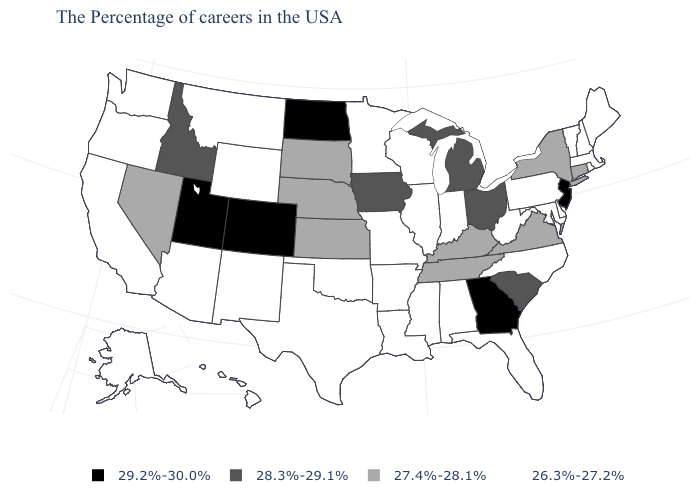Among the states that border Oklahoma , which have the lowest value?
Short answer required. Missouri, Arkansas, Texas, New Mexico. Which states hav the highest value in the West?
Answer briefly. Colorado, Utah. Name the states that have a value in the range 26.3%-27.2%?
Answer briefly. Maine, Massachusetts, Rhode Island, New Hampshire, Vermont, Delaware, Maryland, Pennsylvania, North Carolina, West Virginia, Florida, Indiana, Alabama, Wisconsin, Illinois, Mississippi, Louisiana, Missouri, Arkansas, Minnesota, Oklahoma, Texas, Wyoming, New Mexico, Montana, Arizona, California, Washington, Oregon, Alaska, Hawaii. Which states hav the highest value in the South?
Write a very short answer. Georgia. What is the value of Alabama?
Short answer required. 26.3%-27.2%. What is the value of Louisiana?
Keep it brief. 26.3%-27.2%. What is the value of Pennsylvania?
Write a very short answer. 26.3%-27.2%. Name the states that have a value in the range 27.4%-28.1%?
Keep it brief. Connecticut, New York, Virginia, Kentucky, Tennessee, Kansas, Nebraska, South Dakota, Nevada. Name the states that have a value in the range 28.3%-29.1%?
Quick response, please. South Carolina, Ohio, Michigan, Iowa, Idaho. What is the highest value in the Northeast ?
Keep it brief. 29.2%-30.0%. Name the states that have a value in the range 29.2%-30.0%?
Concise answer only. New Jersey, Georgia, North Dakota, Colorado, Utah. Name the states that have a value in the range 28.3%-29.1%?
Answer briefly. South Carolina, Ohio, Michigan, Iowa, Idaho. What is the value of New Hampshire?
Be succinct. 26.3%-27.2%. Which states have the lowest value in the USA?
Be succinct. Maine, Massachusetts, Rhode Island, New Hampshire, Vermont, Delaware, Maryland, Pennsylvania, North Carolina, West Virginia, Florida, Indiana, Alabama, Wisconsin, Illinois, Mississippi, Louisiana, Missouri, Arkansas, Minnesota, Oklahoma, Texas, Wyoming, New Mexico, Montana, Arizona, California, Washington, Oregon, Alaska, Hawaii. Does Idaho have the lowest value in the West?
Give a very brief answer. No. 